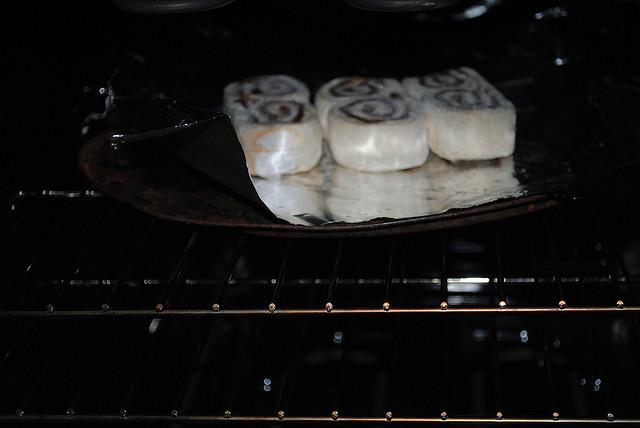Why are the cinnamon buns white?

Choices:
A) food coloring
B) ranch dressing
C) mayonnaise
D) icing icing 